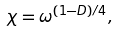<formula> <loc_0><loc_0><loc_500><loc_500>\chi = \omega ^ { ( 1 - D ) / 4 } ,</formula> 